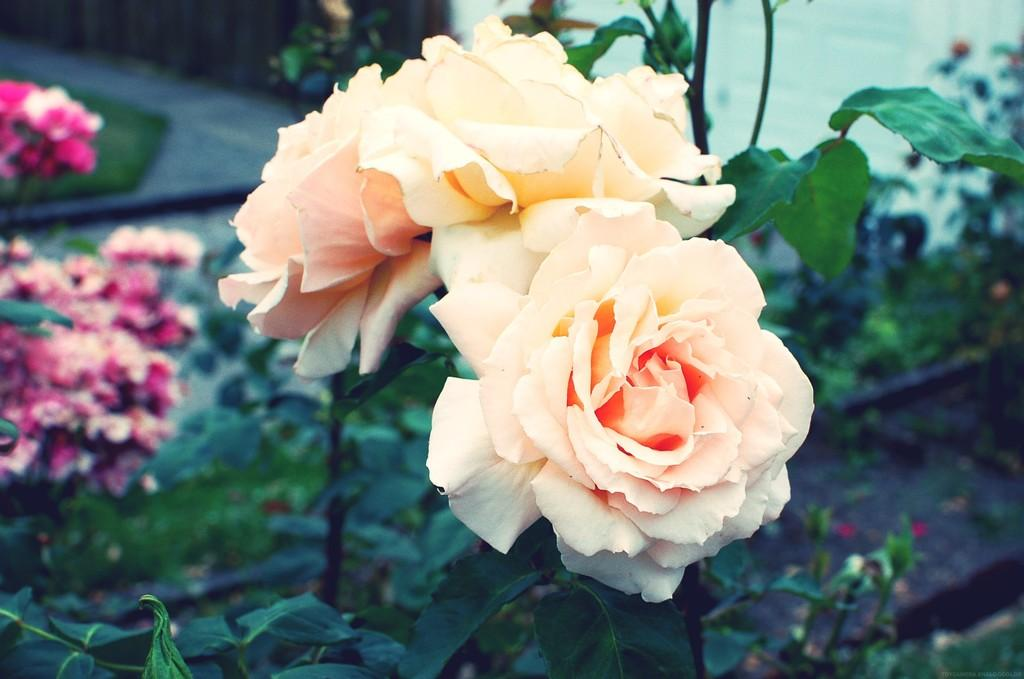What type of living organisms can be seen in the image? There are flowers and plants visible in the image. Can you describe the plants in the image? The plants in the image are not specified, but they are likely green and leafy. What might be the purpose of the flowers in the image? The flowers in the image could be for decoration or may be part of a garden or landscape. What type of ship can be seen sailing in the background of the image? There is no ship present in the image; it only features flowers and plants. 